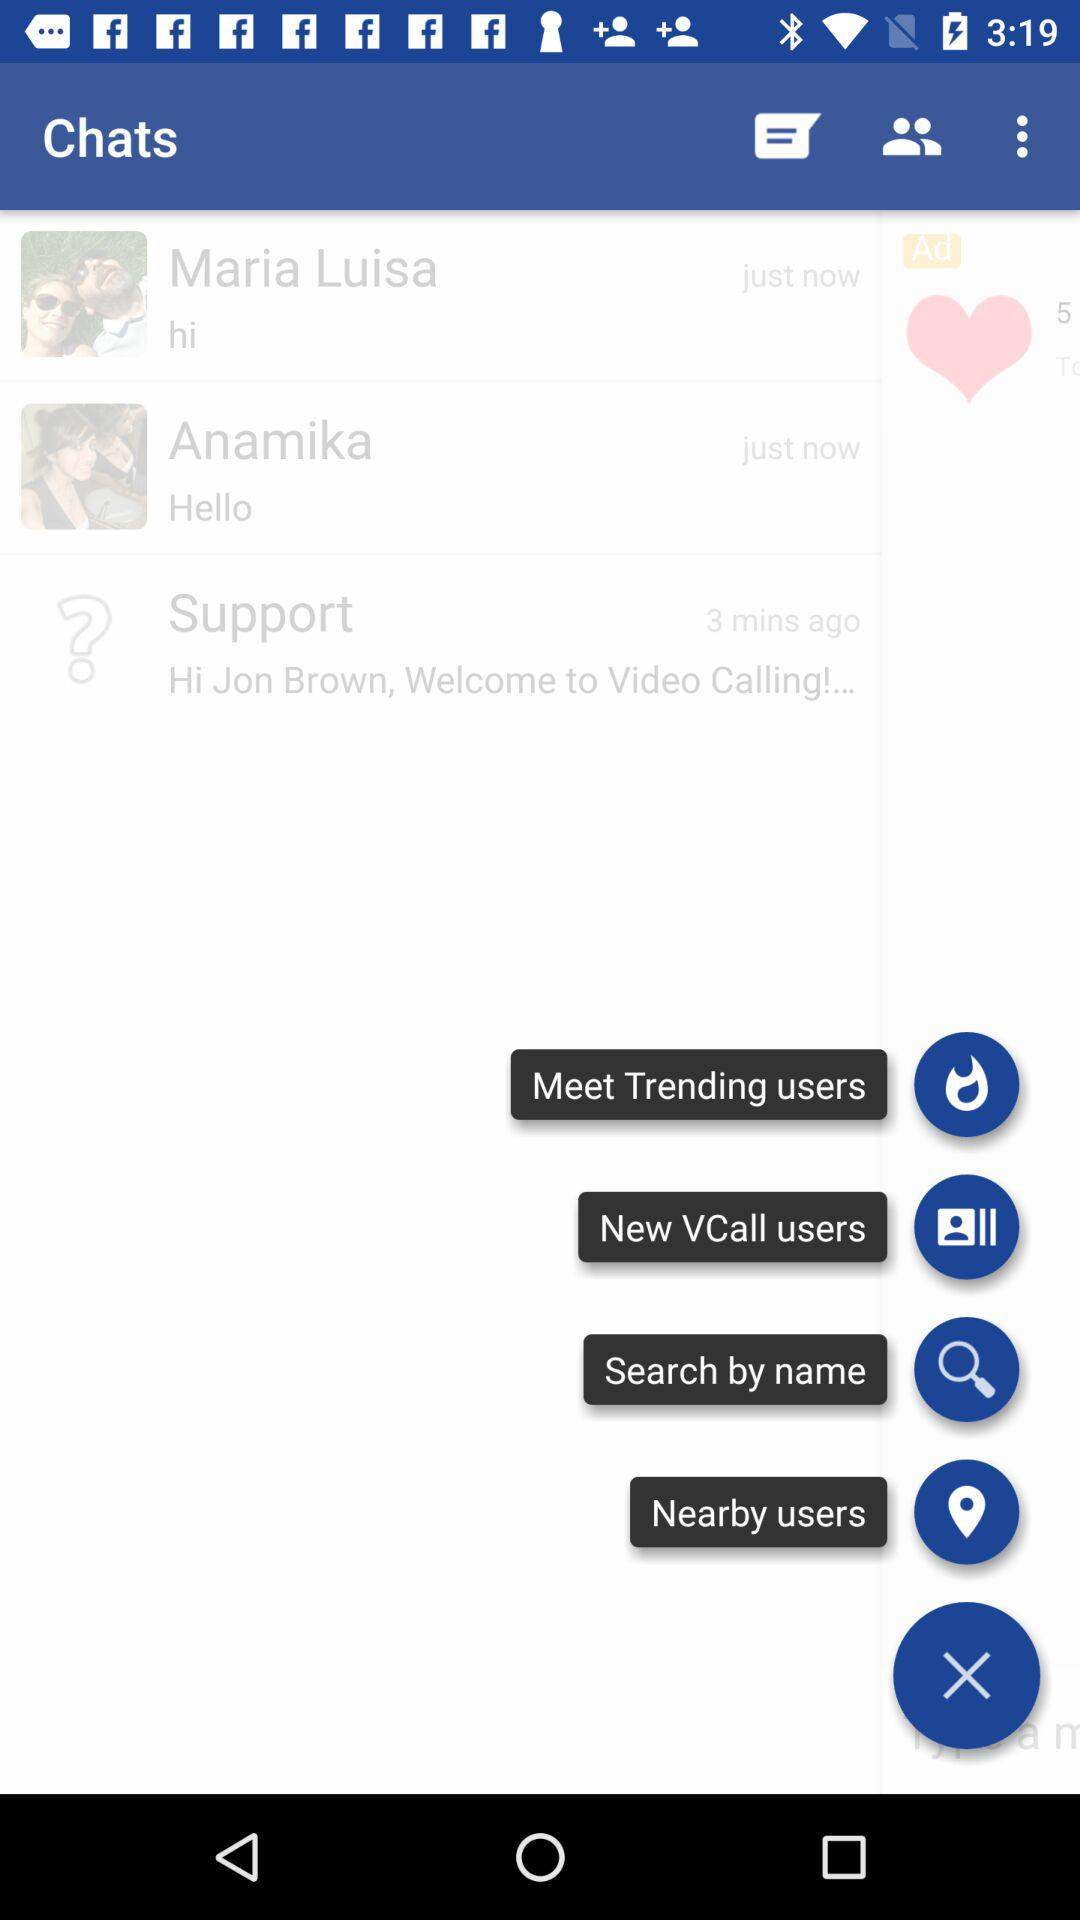When did Anamika's response appear in the chat? It appeared just now. 